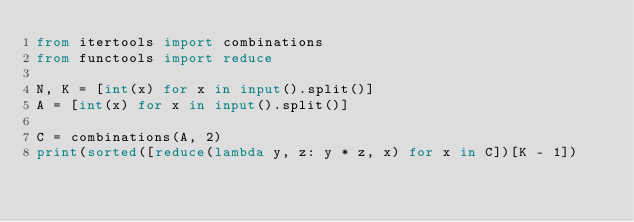Convert code to text. <code><loc_0><loc_0><loc_500><loc_500><_Python_>from itertools import combinations
from functools import reduce

N, K = [int(x) for x in input().split()]
A = [int(x) for x in input().split()]

C = combinations(A, 2)
print(sorted([reduce(lambda y, z: y * z, x) for x in C])[K - 1])</code> 